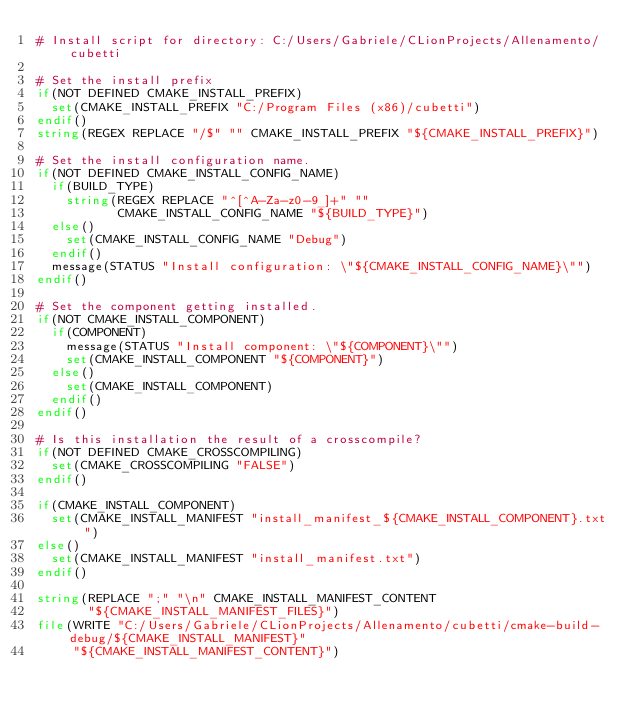Convert code to text. <code><loc_0><loc_0><loc_500><loc_500><_CMake_># Install script for directory: C:/Users/Gabriele/CLionProjects/Allenamento/cubetti

# Set the install prefix
if(NOT DEFINED CMAKE_INSTALL_PREFIX)
  set(CMAKE_INSTALL_PREFIX "C:/Program Files (x86)/cubetti")
endif()
string(REGEX REPLACE "/$" "" CMAKE_INSTALL_PREFIX "${CMAKE_INSTALL_PREFIX}")

# Set the install configuration name.
if(NOT DEFINED CMAKE_INSTALL_CONFIG_NAME)
  if(BUILD_TYPE)
    string(REGEX REPLACE "^[^A-Za-z0-9_]+" ""
           CMAKE_INSTALL_CONFIG_NAME "${BUILD_TYPE}")
  else()
    set(CMAKE_INSTALL_CONFIG_NAME "Debug")
  endif()
  message(STATUS "Install configuration: \"${CMAKE_INSTALL_CONFIG_NAME}\"")
endif()

# Set the component getting installed.
if(NOT CMAKE_INSTALL_COMPONENT)
  if(COMPONENT)
    message(STATUS "Install component: \"${COMPONENT}\"")
    set(CMAKE_INSTALL_COMPONENT "${COMPONENT}")
  else()
    set(CMAKE_INSTALL_COMPONENT)
  endif()
endif()

# Is this installation the result of a crosscompile?
if(NOT DEFINED CMAKE_CROSSCOMPILING)
  set(CMAKE_CROSSCOMPILING "FALSE")
endif()

if(CMAKE_INSTALL_COMPONENT)
  set(CMAKE_INSTALL_MANIFEST "install_manifest_${CMAKE_INSTALL_COMPONENT}.txt")
else()
  set(CMAKE_INSTALL_MANIFEST "install_manifest.txt")
endif()

string(REPLACE ";" "\n" CMAKE_INSTALL_MANIFEST_CONTENT
       "${CMAKE_INSTALL_MANIFEST_FILES}")
file(WRITE "C:/Users/Gabriele/CLionProjects/Allenamento/cubetti/cmake-build-debug/${CMAKE_INSTALL_MANIFEST}"
     "${CMAKE_INSTALL_MANIFEST_CONTENT}")
</code> 